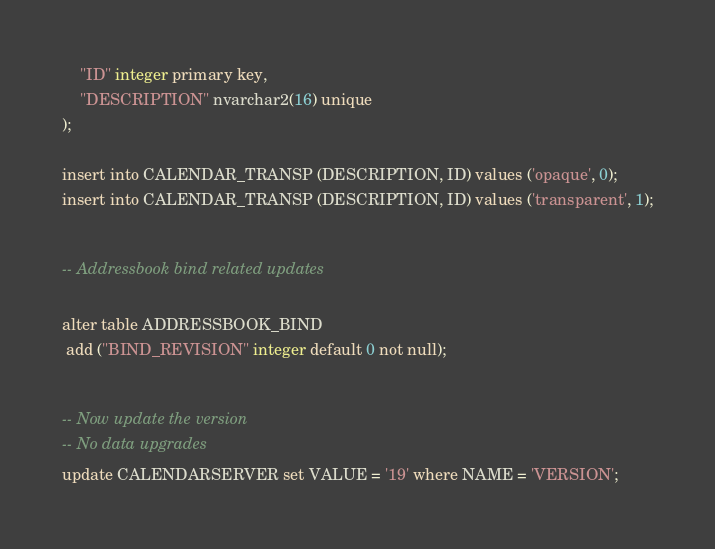Convert code to text. <code><loc_0><loc_0><loc_500><loc_500><_SQL_>    "ID" integer primary key,
    "DESCRIPTION" nvarchar2(16) unique
);

insert into CALENDAR_TRANSP (DESCRIPTION, ID) values ('opaque', 0);
insert into CALENDAR_TRANSP (DESCRIPTION, ID) values ('transparent', 1);

 	  
-- Addressbook bind related updates

alter table ADDRESSBOOK_BIND
 add ("BIND_REVISION" integer default 0 not null);

 
-- Now update the version
-- No data upgrades
update CALENDARSERVER set VALUE = '19' where NAME = 'VERSION';
</code> 